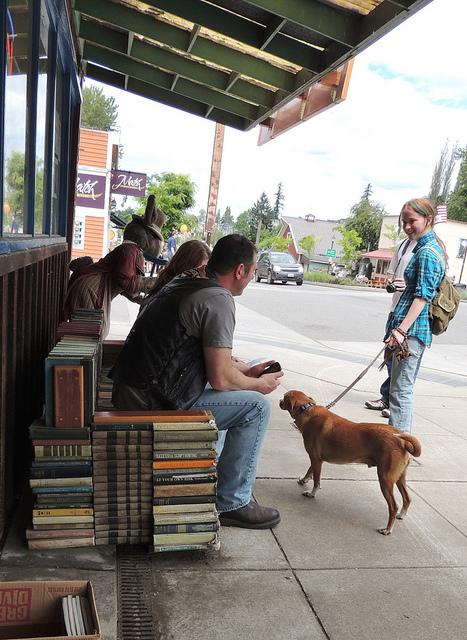Why are they sitting on a pile of books?

Choices:
A) their job
B) found
C) is bookstore
D) are stolen is bookstore 